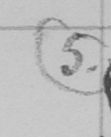Can you read and transcribe this handwriting? ( 5 